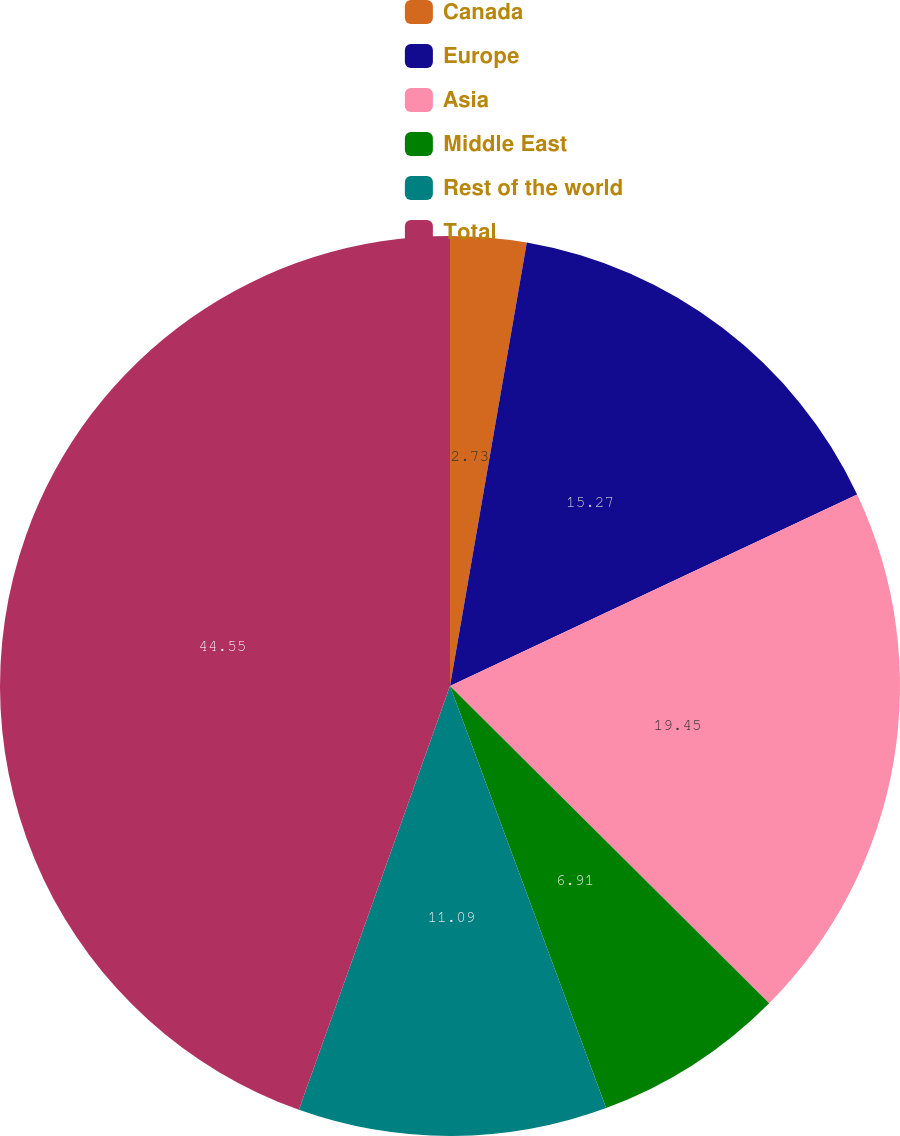<chart> <loc_0><loc_0><loc_500><loc_500><pie_chart><fcel>Canada<fcel>Europe<fcel>Asia<fcel>Middle East<fcel>Rest of the world<fcel>Total<nl><fcel>2.73%<fcel>15.27%<fcel>19.45%<fcel>6.91%<fcel>11.09%<fcel>44.55%<nl></chart> 